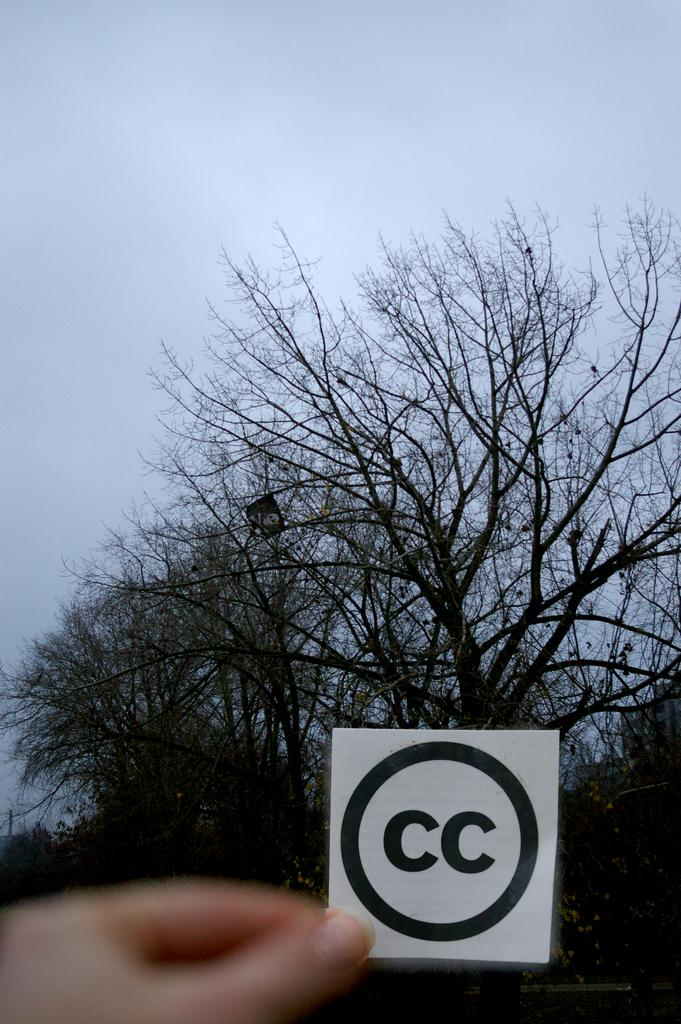What is the main subject of the image? There is a person in the image. What is the person holding in the image? The person is holding a sign sticker. What can be seen in the background of the image? There are trees visible in the background of the image. What else is visible in the image? The sky is visible in the image. How many cakes are being carried by the flock of birds in the image? There are no birds or cakes present in the image. 